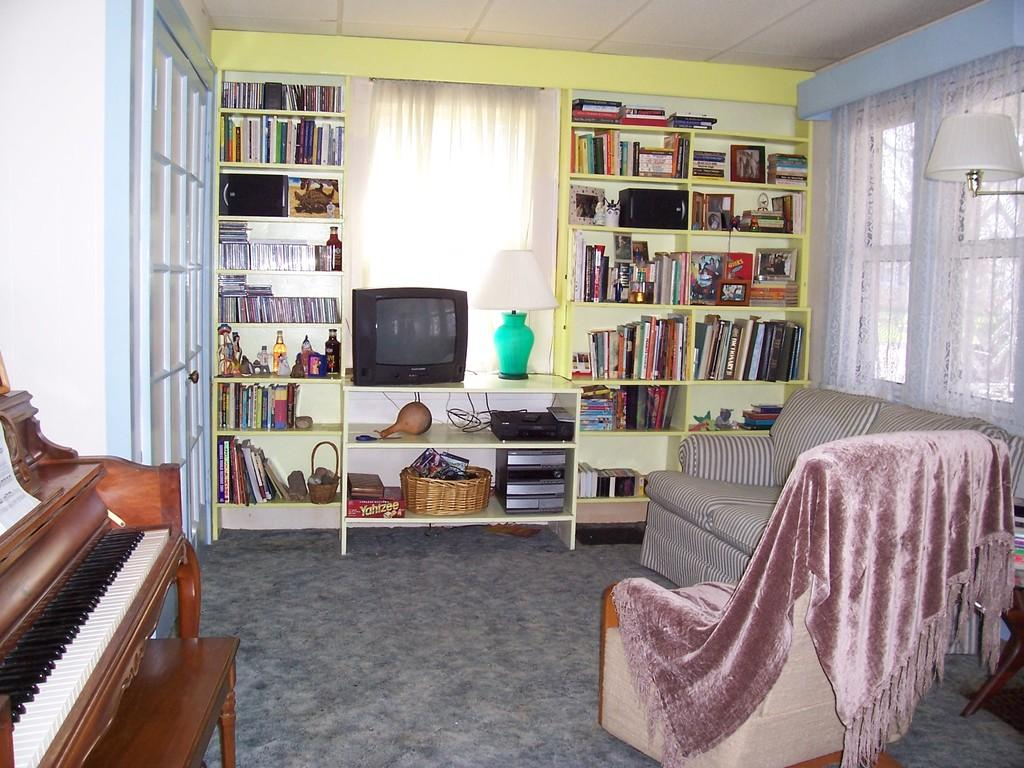What type of furniture is present in the room? There is a sofa set in the room. What musical instrument can be found in the room? There is a piano in the room. What electronic device is in the room? There is a television in the room. What audio equipment is present in the room? There are speakers in the room. What reading materials are available in the room? There are books in the room. What source of light is in the room? There is a lamp in the room. What window treatment is present in the room? There are curtains in the room. What type of storage containers are in the room? There are baskets in the room. What type of peace symbol can be seen hanging on the wall in the room? There is no peace symbol mentioned in the provided facts, and therefore no such symbol can be seen hanging on the wall in the room. 